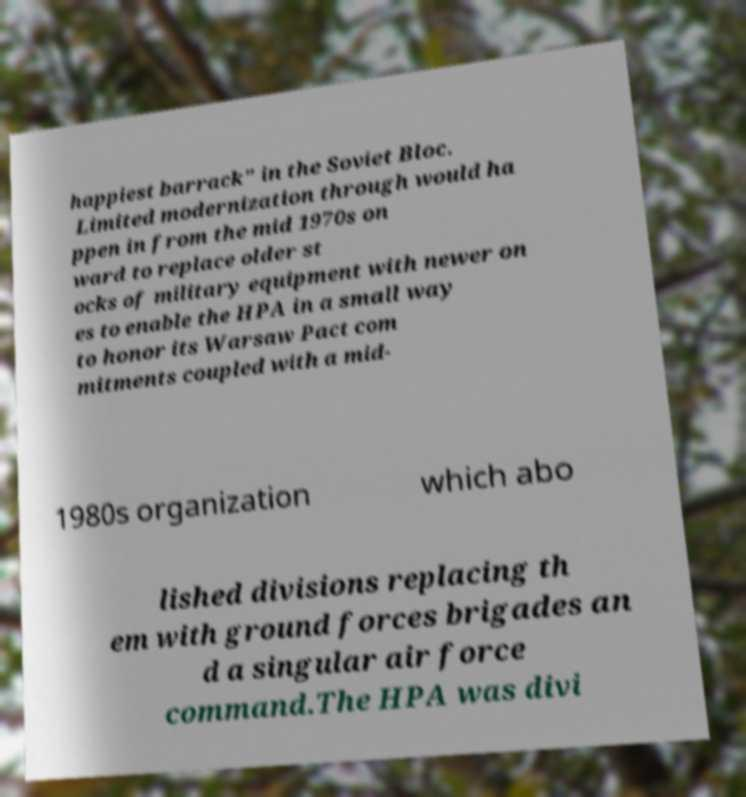Can you accurately transcribe the text from the provided image for me? happiest barrack" in the Soviet Bloc. Limited modernization through would ha ppen in from the mid 1970s on ward to replace older st ocks of military equipment with newer on es to enable the HPA in a small way to honor its Warsaw Pact com mitments coupled with a mid- 1980s organization which abo lished divisions replacing th em with ground forces brigades an d a singular air force command.The HPA was divi 